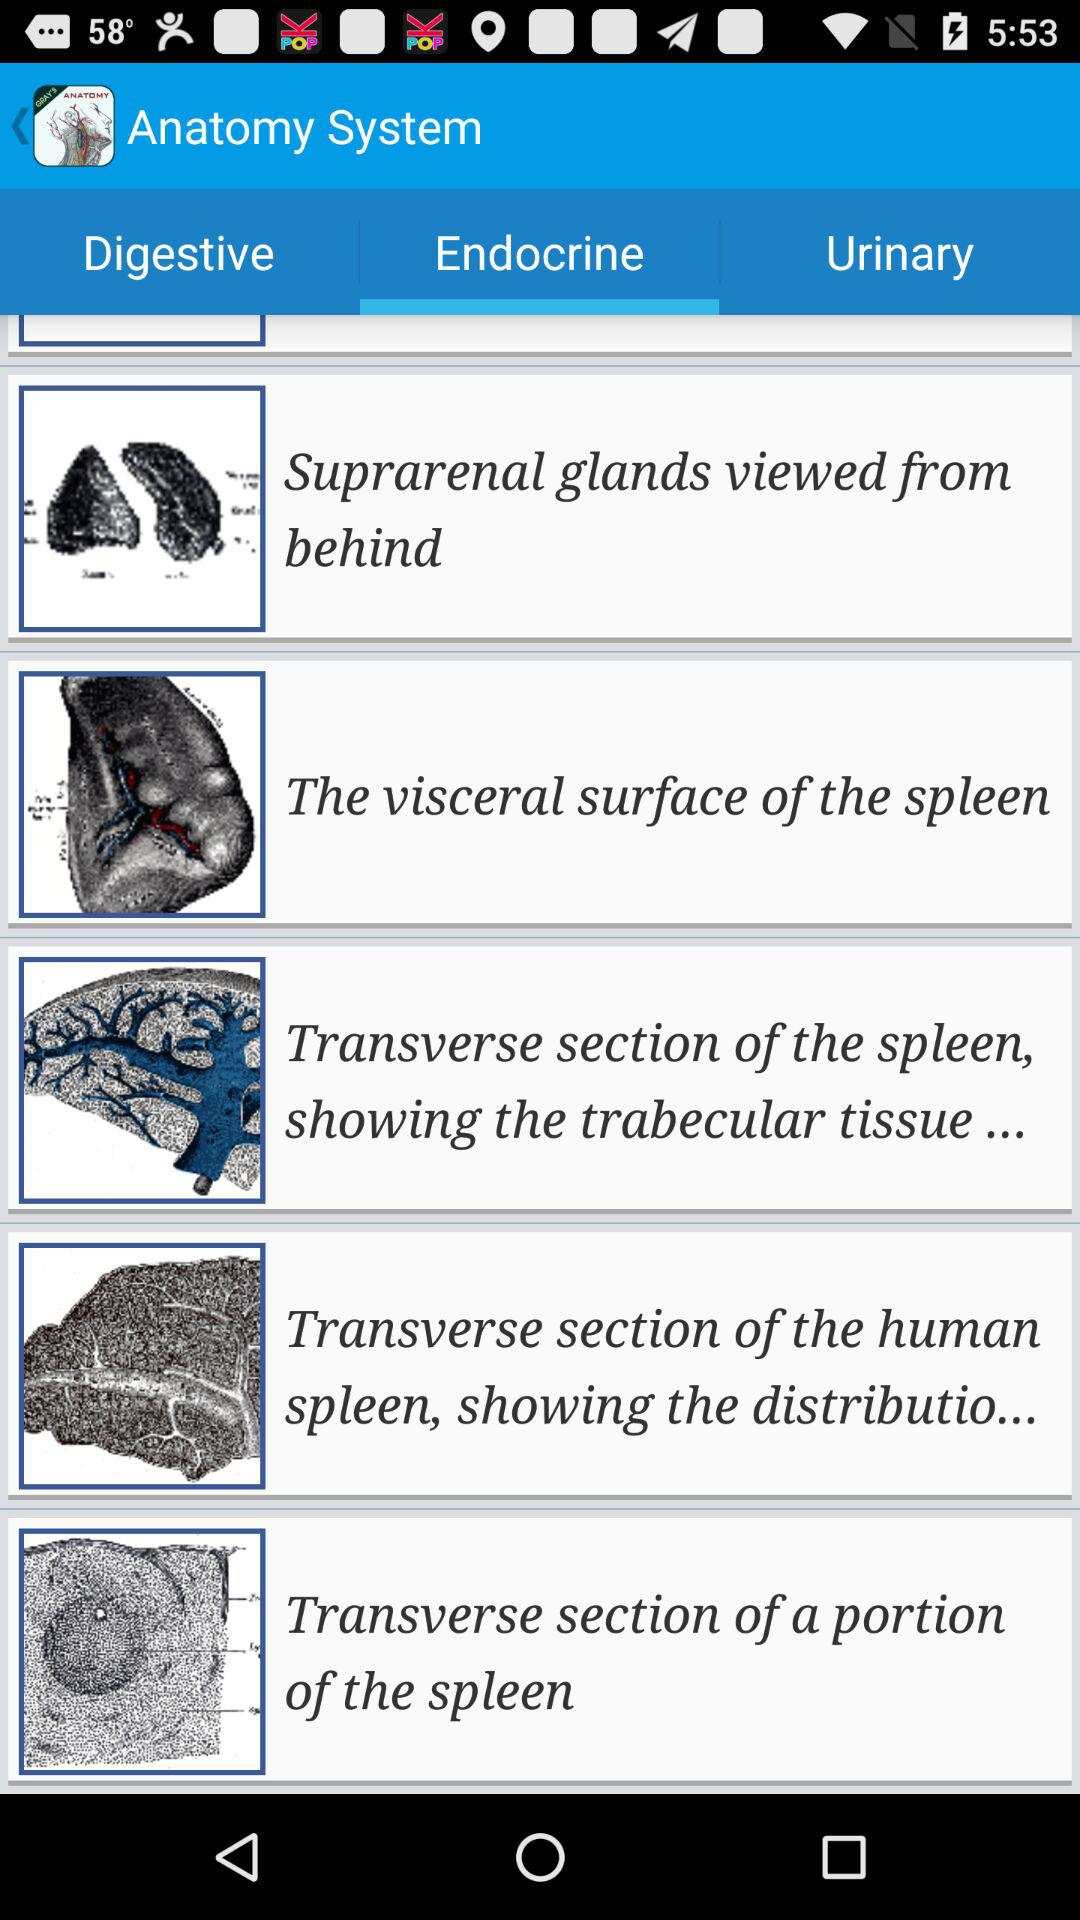Which tab is selected? The selected tab is Endocrine. 